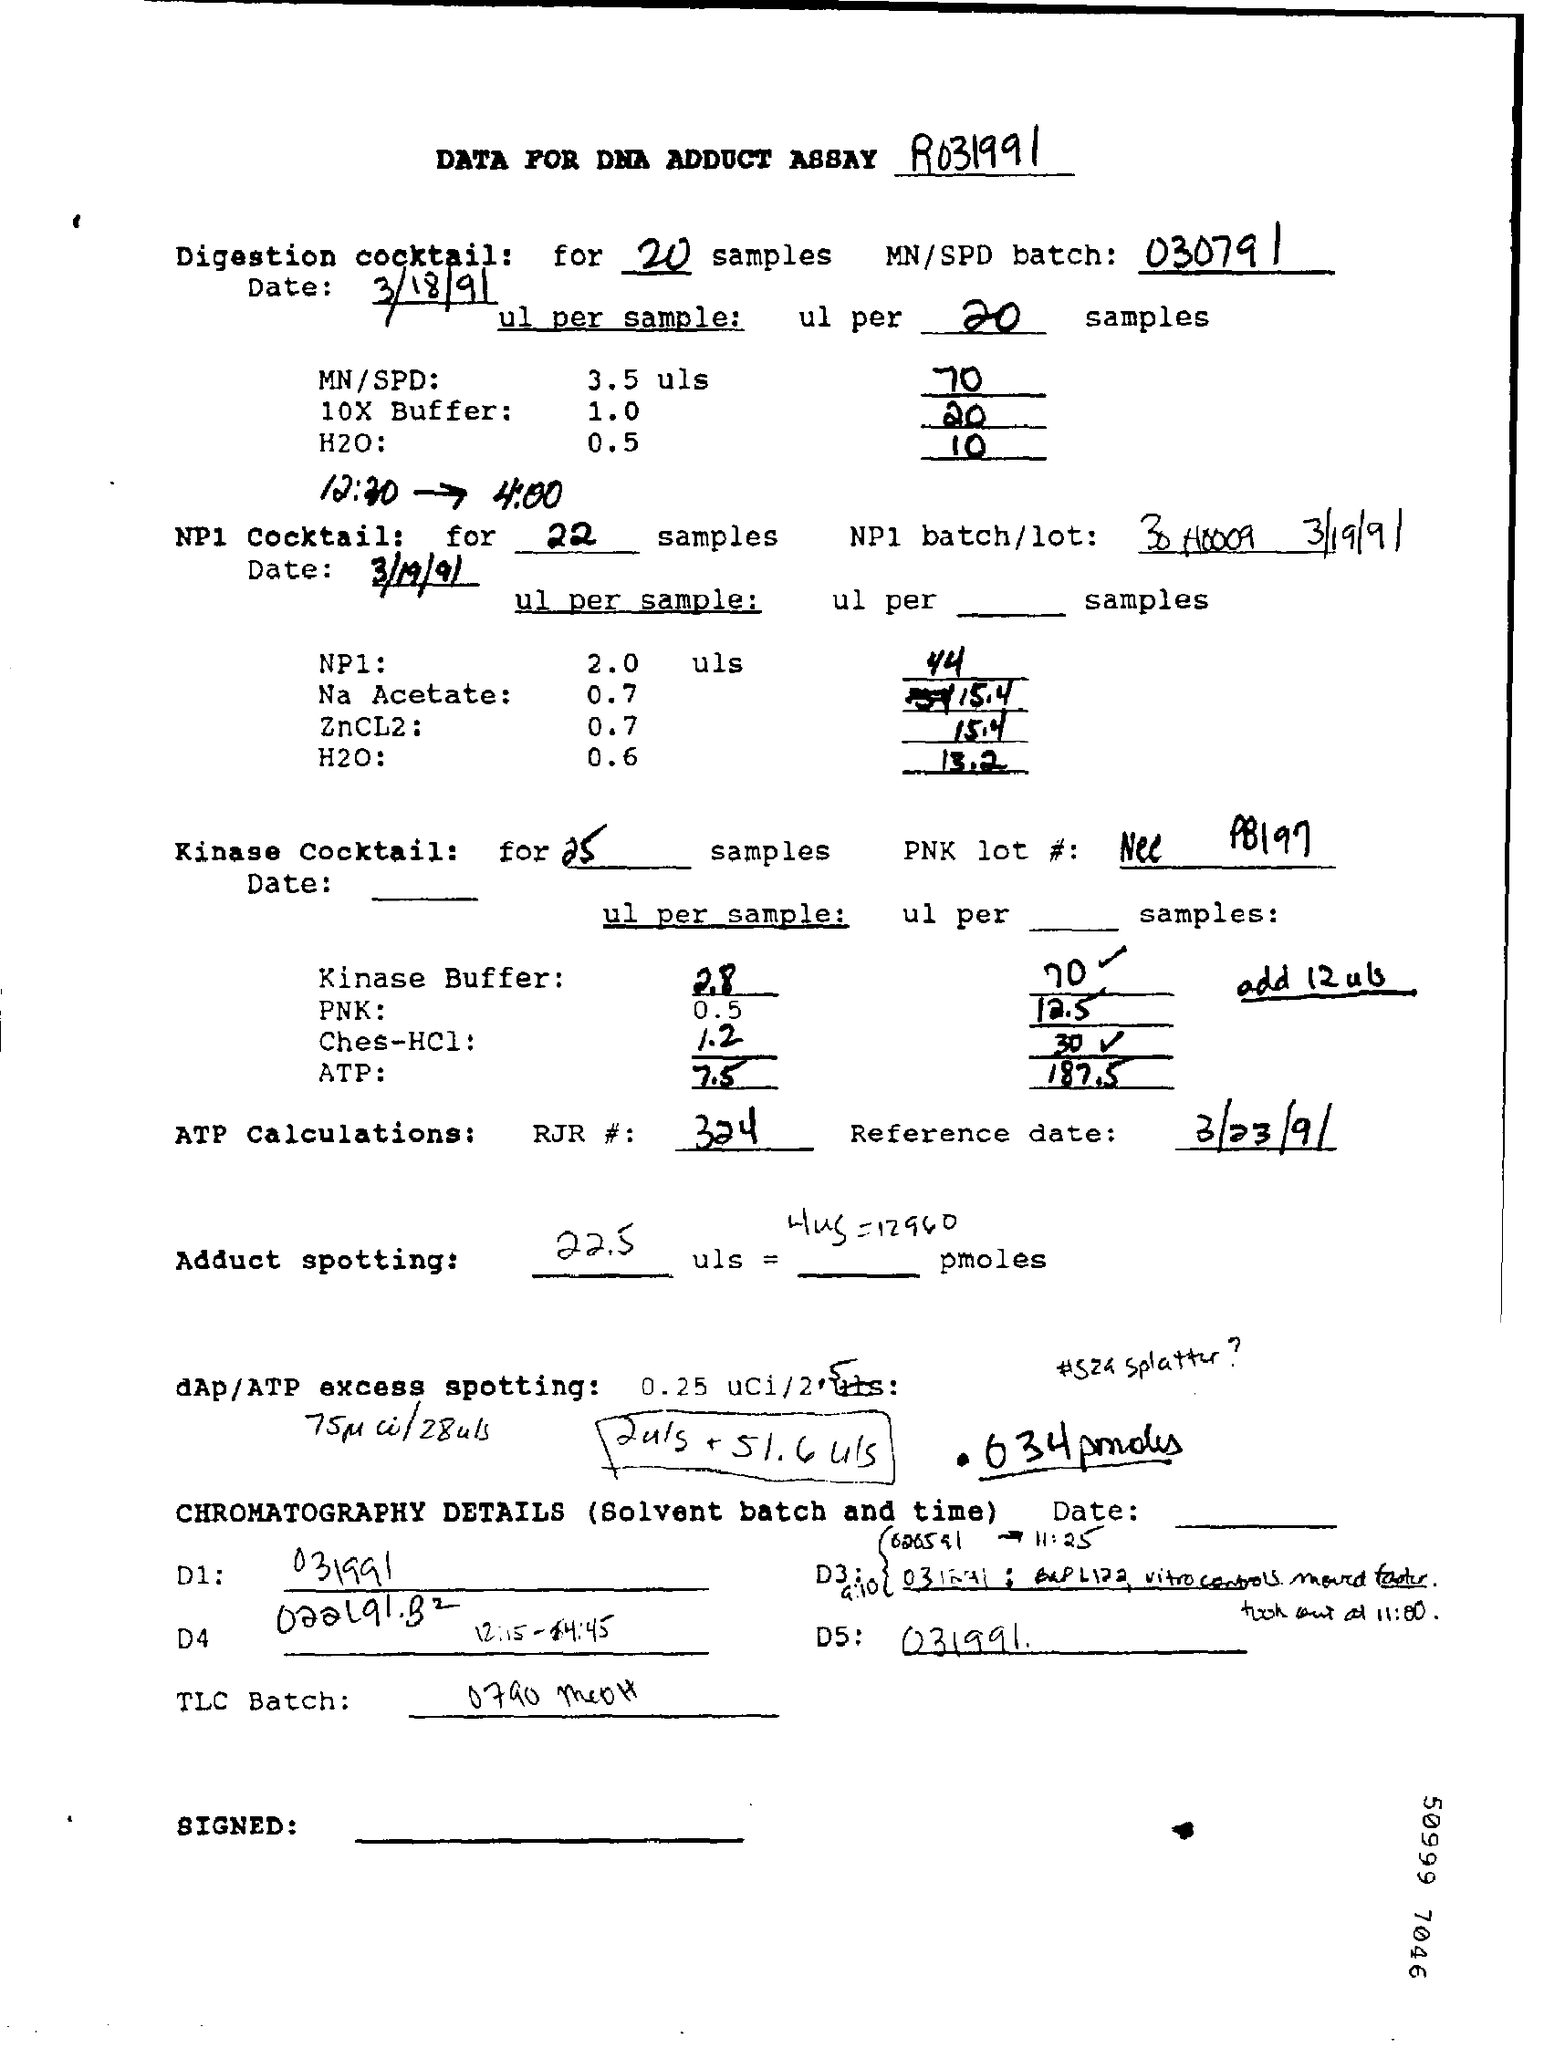How many samples for Digestion cocktail ?
Make the answer very short. 20. What is the date of testing for digestion cocktail ?
Your response must be concise. 3/18/91. 